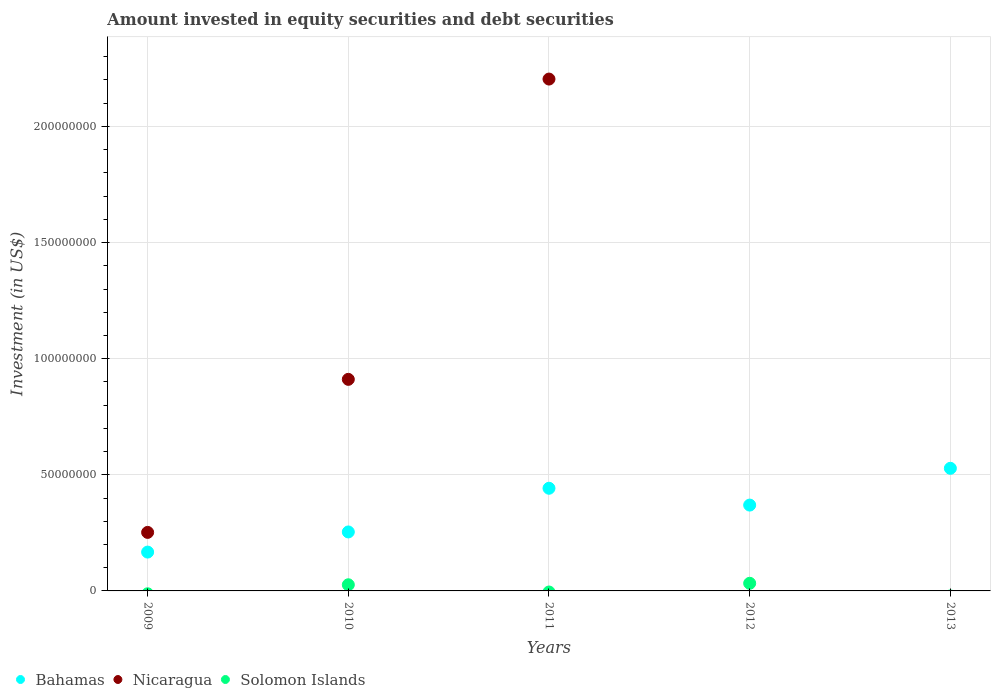Is the number of dotlines equal to the number of legend labels?
Keep it short and to the point. No. What is the amount invested in equity securities and debt securities in Nicaragua in 2009?
Give a very brief answer. 2.52e+07. Across all years, what is the maximum amount invested in equity securities and debt securities in Bahamas?
Ensure brevity in your answer.  5.28e+07. Across all years, what is the minimum amount invested in equity securities and debt securities in Nicaragua?
Your answer should be very brief. 0. What is the total amount invested in equity securities and debt securities in Nicaragua in the graph?
Your response must be concise. 3.37e+08. What is the difference between the amount invested in equity securities and debt securities in Bahamas in 2012 and that in 2013?
Offer a terse response. -1.58e+07. What is the difference between the amount invested in equity securities and debt securities in Bahamas in 2013 and the amount invested in equity securities and debt securities in Nicaragua in 2012?
Your answer should be very brief. 5.28e+07. What is the average amount invested in equity securities and debt securities in Solomon Islands per year?
Ensure brevity in your answer.  1.19e+06. In the year 2010, what is the difference between the amount invested in equity securities and debt securities in Bahamas and amount invested in equity securities and debt securities in Nicaragua?
Offer a terse response. -6.57e+07. What is the ratio of the amount invested in equity securities and debt securities in Nicaragua in 2009 to that in 2011?
Provide a succinct answer. 0.11. Is the difference between the amount invested in equity securities and debt securities in Bahamas in 2010 and 2011 greater than the difference between the amount invested in equity securities and debt securities in Nicaragua in 2010 and 2011?
Give a very brief answer. Yes. What is the difference between the highest and the second highest amount invested in equity securities and debt securities in Nicaragua?
Give a very brief answer. 1.29e+08. What is the difference between the highest and the lowest amount invested in equity securities and debt securities in Nicaragua?
Your answer should be compact. 2.20e+08. In how many years, is the amount invested in equity securities and debt securities in Solomon Islands greater than the average amount invested in equity securities and debt securities in Solomon Islands taken over all years?
Offer a terse response. 2. Is the sum of the amount invested in equity securities and debt securities in Bahamas in 2009 and 2013 greater than the maximum amount invested in equity securities and debt securities in Solomon Islands across all years?
Your answer should be very brief. Yes. Is the amount invested in equity securities and debt securities in Solomon Islands strictly greater than the amount invested in equity securities and debt securities in Nicaragua over the years?
Your answer should be very brief. No. What is the difference between two consecutive major ticks on the Y-axis?
Your answer should be very brief. 5.00e+07. Does the graph contain grids?
Make the answer very short. Yes. Where does the legend appear in the graph?
Provide a succinct answer. Bottom left. How many legend labels are there?
Provide a succinct answer. 3. How are the legend labels stacked?
Your answer should be compact. Horizontal. What is the title of the graph?
Your answer should be very brief. Amount invested in equity securities and debt securities. Does "Nigeria" appear as one of the legend labels in the graph?
Offer a very short reply. No. What is the label or title of the Y-axis?
Offer a very short reply. Investment (in US$). What is the Investment (in US$) of Bahamas in 2009?
Give a very brief answer. 1.67e+07. What is the Investment (in US$) of Nicaragua in 2009?
Your response must be concise. 2.52e+07. What is the Investment (in US$) in Bahamas in 2010?
Make the answer very short. 2.54e+07. What is the Investment (in US$) in Nicaragua in 2010?
Your answer should be compact. 9.11e+07. What is the Investment (in US$) in Solomon Islands in 2010?
Provide a short and direct response. 2.65e+06. What is the Investment (in US$) of Bahamas in 2011?
Your response must be concise. 4.42e+07. What is the Investment (in US$) of Nicaragua in 2011?
Offer a very short reply. 2.20e+08. What is the Investment (in US$) of Bahamas in 2012?
Offer a very short reply. 3.70e+07. What is the Investment (in US$) of Nicaragua in 2012?
Offer a very short reply. 0. What is the Investment (in US$) of Solomon Islands in 2012?
Give a very brief answer. 3.29e+06. What is the Investment (in US$) in Bahamas in 2013?
Provide a succinct answer. 5.28e+07. What is the Investment (in US$) of Solomon Islands in 2013?
Provide a succinct answer. 0. Across all years, what is the maximum Investment (in US$) of Bahamas?
Your answer should be very brief. 5.28e+07. Across all years, what is the maximum Investment (in US$) of Nicaragua?
Provide a succinct answer. 2.20e+08. Across all years, what is the maximum Investment (in US$) in Solomon Islands?
Make the answer very short. 3.29e+06. Across all years, what is the minimum Investment (in US$) in Bahamas?
Your answer should be very brief. 1.67e+07. Across all years, what is the minimum Investment (in US$) of Nicaragua?
Make the answer very short. 0. Across all years, what is the minimum Investment (in US$) in Solomon Islands?
Your response must be concise. 0. What is the total Investment (in US$) of Bahamas in the graph?
Your response must be concise. 1.76e+08. What is the total Investment (in US$) of Nicaragua in the graph?
Provide a short and direct response. 3.37e+08. What is the total Investment (in US$) of Solomon Islands in the graph?
Offer a terse response. 5.94e+06. What is the difference between the Investment (in US$) of Bahamas in 2009 and that in 2010?
Give a very brief answer. -8.67e+06. What is the difference between the Investment (in US$) in Nicaragua in 2009 and that in 2010?
Provide a short and direct response. -6.59e+07. What is the difference between the Investment (in US$) of Bahamas in 2009 and that in 2011?
Keep it short and to the point. -2.75e+07. What is the difference between the Investment (in US$) of Nicaragua in 2009 and that in 2011?
Keep it short and to the point. -1.95e+08. What is the difference between the Investment (in US$) in Bahamas in 2009 and that in 2012?
Offer a very short reply. -2.02e+07. What is the difference between the Investment (in US$) of Bahamas in 2009 and that in 2013?
Make the answer very short. -3.61e+07. What is the difference between the Investment (in US$) in Bahamas in 2010 and that in 2011?
Your answer should be compact. -1.88e+07. What is the difference between the Investment (in US$) of Nicaragua in 2010 and that in 2011?
Offer a terse response. -1.29e+08. What is the difference between the Investment (in US$) of Bahamas in 2010 and that in 2012?
Ensure brevity in your answer.  -1.16e+07. What is the difference between the Investment (in US$) in Solomon Islands in 2010 and that in 2012?
Ensure brevity in your answer.  -6.40e+05. What is the difference between the Investment (in US$) of Bahamas in 2010 and that in 2013?
Your answer should be compact. -2.74e+07. What is the difference between the Investment (in US$) of Bahamas in 2011 and that in 2012?
Offer a very short reply. 7.24e+06. What is the difference between the Investment (in US$) of Bahamas in 2011 and that in 2013?
Give a very brief answer. -8.59e+06. What is the difference between the Investment (in US$) of Bahamas in 2012 and that in 2013?
Provide a succinct answer. -1.58e+07. What is the difference between the Investment (in US$) in Bahamas in 2009 and the Investment (in US$) in Nicaragua in 2010?
Your answer should be compact. -7.44e+07. What is the difference between the Investment (in US$) of Bahamas in 2009 and the Investment (in US$) of Solomon Islands in 2010?
Offer a very short reply. 1.41e+07. What is the difference between the Investment (in US$) of Nicaragua in 2009 and the Investment (in US$) of Solomon Islands in 2010?
Give a very brief answer. 2.26e+07. What is the difference between the Investment (in US$) in Bahamas in 2009 and the Investment (in US$) in Nicaragua in 2011?
Your answer should be compact. -2.04e+08. What is the difference between the Investment (in US$) of Bahamas in 2009 and the Investment (in US$) of Solomon Islands in 2012?
Offer a very short reply. 1.34e+07. What is the difference between the Investment (in US$) of Nicaragua in 2009 and the Investment (in US$) of Solomon Islands in 2012?
Your answer should be compact. 2.19e+07. What is the difference between the Investment (in US$) in Bahamas in 2010 and the Investment (in US$) in Nicaragua in 2011?
Provide a succinct answer. -1.95e+08. What is the difference between the Investment (in US$) of Bahamas in 2010 and the Investment (in US$) of Solomon Islands in 2012?
Make the answer very short. 2.21e+07. What is the difference between the Investment (in US$) of Nicaragua in 2010 and the Investment (in US$) of Solomon Islands in 2012?
Offer a terse response. 8.78e+07. What is the difference between the Investment (in US$) in Bahamas in 2011 and the Investment (in US$) in Solomon Islands in 2012?
Provide a succinct answer. 4.09e+07. What is the difference between the Investment (in US$) of Nicaragua in 2011 and the Investment (in US$) of Solomon Islands in 2012?
Make the answer very short. 2.17e+08. What is the average Investment (in US$) in Bahamas per year?
Your answer should be very brief. 3.52e+07. What is the average Investment (in US$) in Nicaragua per year?
Provide a short and direct response. 6.73e+07. What is the average Investment (in US$) in Solomon Islands per year?
Provide a short and direct response. 1.19e+06. In the year 2009, what is the difference between the Investment (in US$) in Bahamas and Investment (in US$) in Nicaragua?
Your answer should be very brief. -8.48e+06. In the year 2010, what is the difference between the Investment (in US$) of Bahamas and Investment (in US$) of Nicaragua?
Offer a terse response. -6.57e+07. In the year 2010, what is the difference between the Investment (in US$) of Bahamas and Investment (in US$) of Solomon Islands?
Provide a succinct answer. 2.27e+07. In the year 2010, what is the difference between the Investment (in US$) of Nicaragua and Investment (in US$) of Solomon Islands?
Keep it short and to the point. 8.85e+07. In the year 2011, what is the difference between the Investment (in US$) of Bahamas and Investment (in US$) of Nicaragua?
Your response must be concise. -1.76e+08. In the year 2012, what is the difference between the Investment (in US$) in Bahamas and Investment (in US$) in Solomon Islands?
Give a very brief answer. 3.37e+07. What is the ratio of the Investment (in US$) in Bahamas in 2009 to that in 2010?
Your answer should be very brief. 0.66. What is the ratio of the Investment (in US$) in Nicaragua in 2009 to that in 2010?
Provide a short and direct response. 0.28. What is the ratio of the Investment (in US$) of Bahamas in 2009 to that in 2011?
Offer a terse response. 0.38. What is the ratio of the Investment (in US$) in Nicaragua in 2009 to that in 2011?
Provide a succinct answer. 0.11. What is the ratio of the Investment (in US$) in Bahamas in 2009 to that in 2012?
Keep it short and to the point. 0.45. What is the ratio of the Investment (in US$) in Bahamas in 2009 to that in 2013?
Your response must be concise. 0.32. What is the ratio of the Investment (in US$) in Bahamas in 2010 to that in 2011?
Make the answer very short. 0.57. What is the ratio of the Investment (in US$) of Nicaragua in 2010 to that in 2011?
Keep it short and to the point. 0.41. What is the ratio of the Investment (in US$) of Bahamas in 2010 to that in 2012?
Ensure brevity in your answer.  0.69. What is the ratio of the Investment (in US$) in Solomon Islands in 2010 to that in 2012?
Keep it short and to the point. 0.81. What is the ratio of the Investment (in US$) in Bahamas in 2010 to that in 2013?
Your answer should be very brief. 0.48. What is the ratio of the Investment (in US$) of Bahamas in 2011 to that in 2012?
Offer a terse response. 1.2. What is the ratio of the Investment (in US$) of Bahamas in 2011 to that in 2013?
Your response must be concise. 0.84. What is the ratio of the Investment (in US$) in Bahamas in 2012 to that in 2013?
Offer a very short reply. 0.7. What is the difference between the highest and the second highest Investment (in US$) of Bahamas?
Offer a very short reply. 8.59e+06. What is the difference between the highest and the second highest Investment (in US$) of Nicaragua?
Give a very brief answer. 1.29e+08. What is the difference between the highest and the lowest Investment (in US$) of Bahamas?
Offer a terse response. 3.61e+07. What is the difference between the highest and the lowest Investment (in US$) in Nicaragua?
Your answer should be compact. 2.20e+08. What is the difference between the highest and the lowest Investment (in US$) in Solomon Islands?
Your response must be concise. 3.29e+06. 